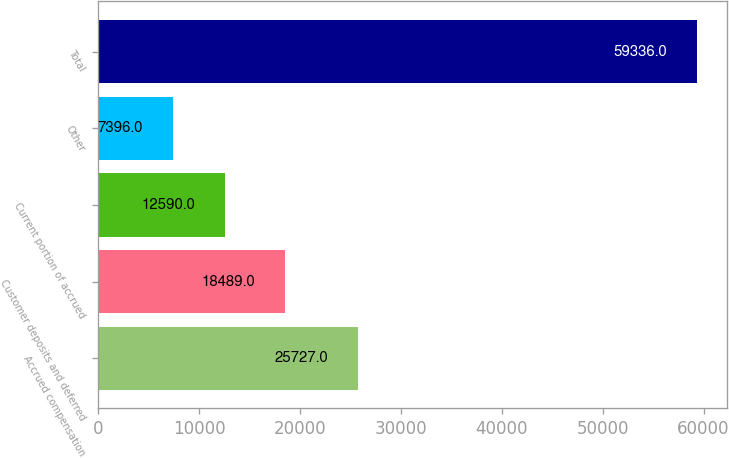Convert chart. <chart><loc_0><loc_0><loc_500><loc_500><bar_chart><fcel>Accrued compensation<fcel>Customer deposits and deferred<fcel>Current portion of accrued<fcel>Other<fcel>Total<nl><fcel>25727<fcel>18489<fcel>12590<fcel>7396<fcel>59336<nl></chart> 